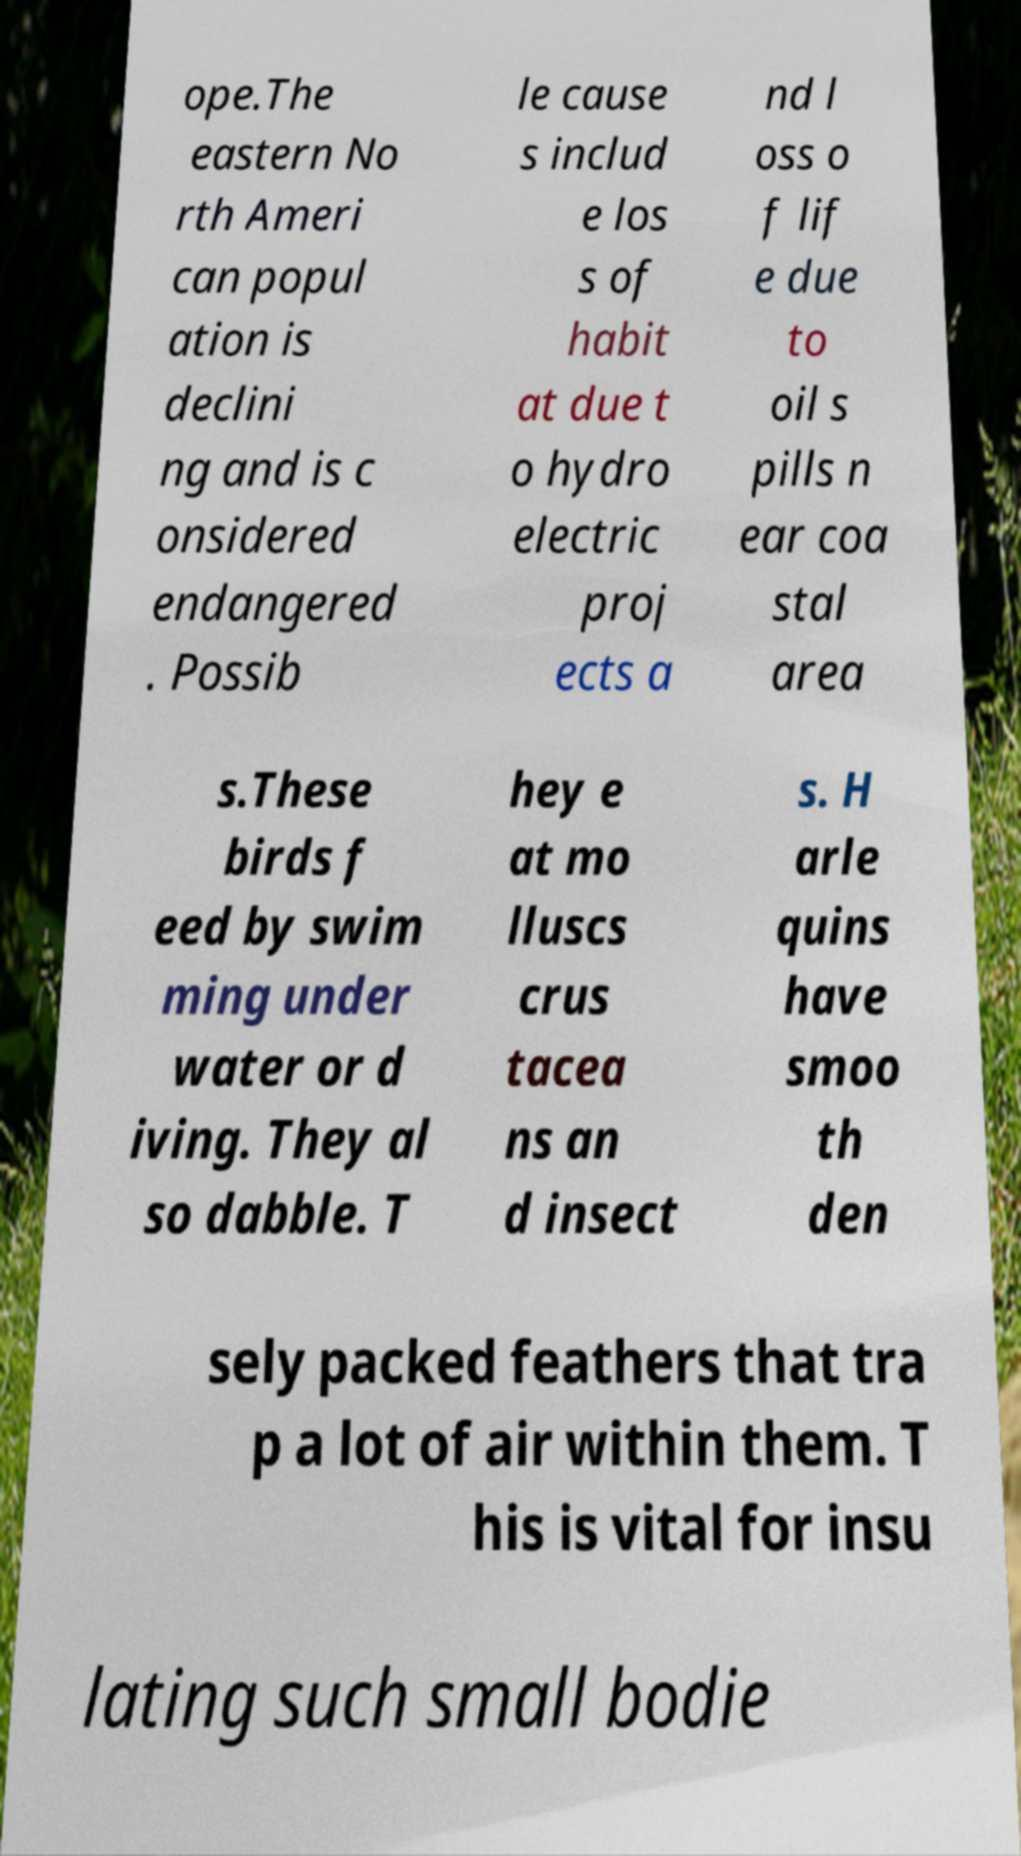For documentation purposes, I need the text within this image transcribed. Could you provide that? ope.The eastern No rth Ameri can popul ation is declini ng and is c onsidered endangered . Possib le cause s includ e los s of habit at due t o hydro electric proj ects a nd l oss o f lif e due to oil s pills n ear coa stal area s.These birds f eed by swim ming under water or d iving. They al so dabble. T hey e at mo lluscs crus tacea ns an d insect s. H arle quins have smoo th den sely packed feathers that tra p a lot of air within them. T his is vital for insu lating such small bodie 